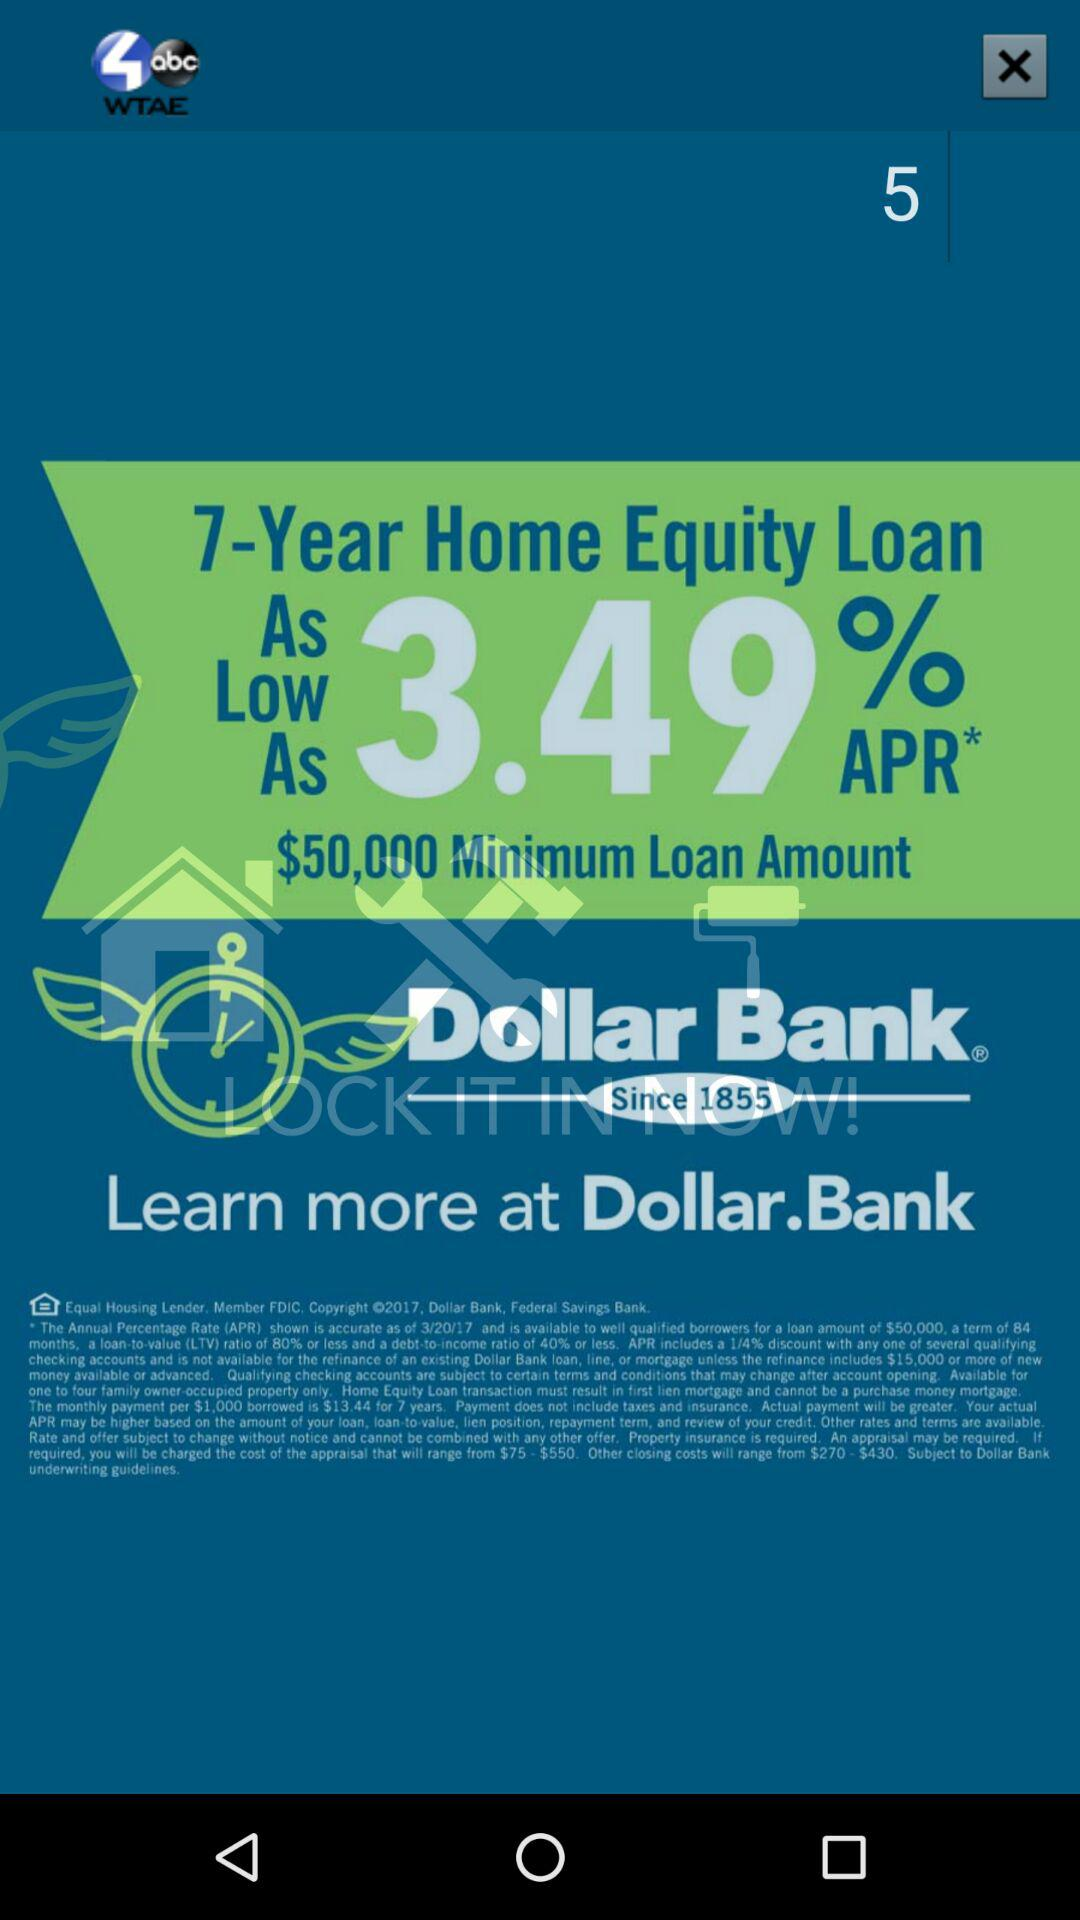How much is the APR for this offer?
Answer the question using a single word or phrase. 3.49% 